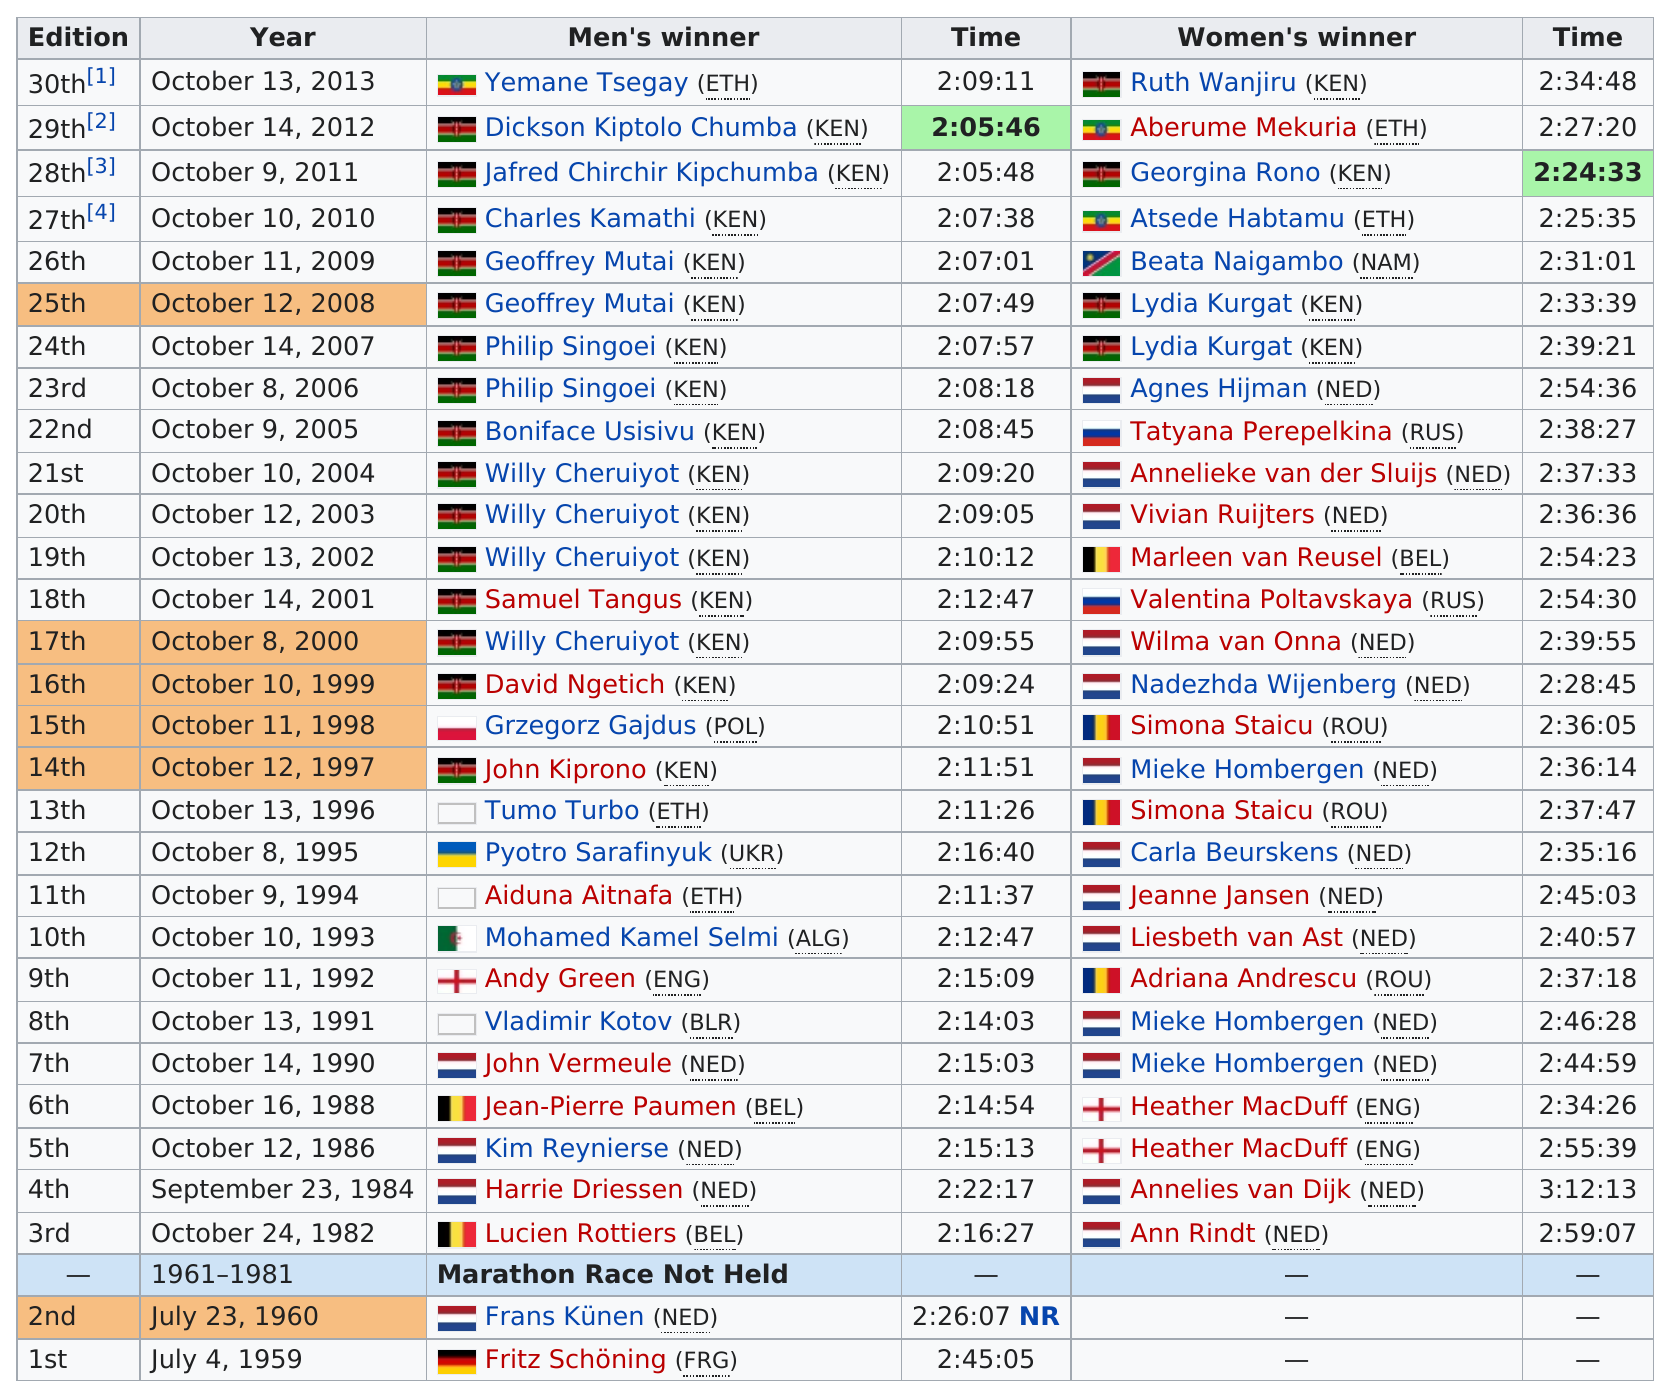Highlight a few significant elements in this photo. There were 19 winners from Kenya. Fritz Schöning (FRG) was the first recorded winner of the Eindhoven Marathon. Mieke Hombergen won the competition three times. In 2013, Yemane Tsegay (of Ethiopia) and Ruth Wanjiru (of Kenya) were the male and female winners, respectively. Agnes Hijman (NED) was the last European woman to win the Eindhoven Marathon. 